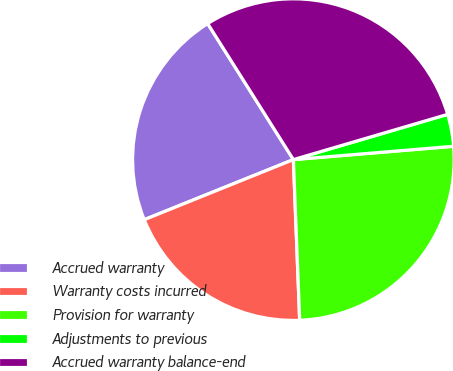<chart> <loc_0><loc_0><loc_500><loc_500><pie_chart><fcel>Accrued warranty<fcel>Warranty costs incurred<fcel>Provision for warranty<fcel>Adjustments to previous<fcel>Accrued warranty balance-end<nl><fcel>22.15%<fcel>19.53%<fcel>25.7%<fcel>3.22%<fcel>29.41%<nl></chart> 